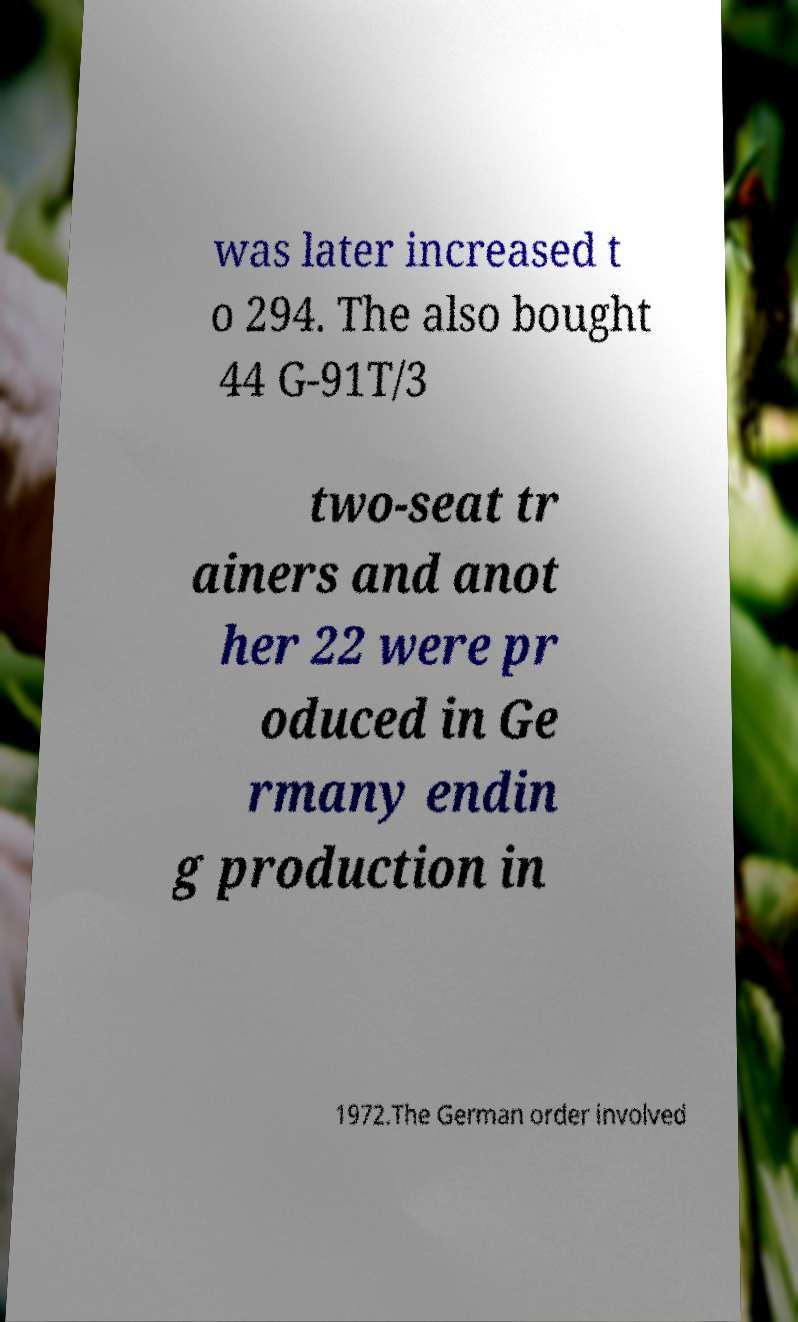Can you accurately transcribe the text from the provided image for me? was later increased t o 294. The also bought 44 G-91T/3 two-seat tr ainers and anot her 22 were pr oduced in Ge rmany endin g production in 1972.The German order involved 